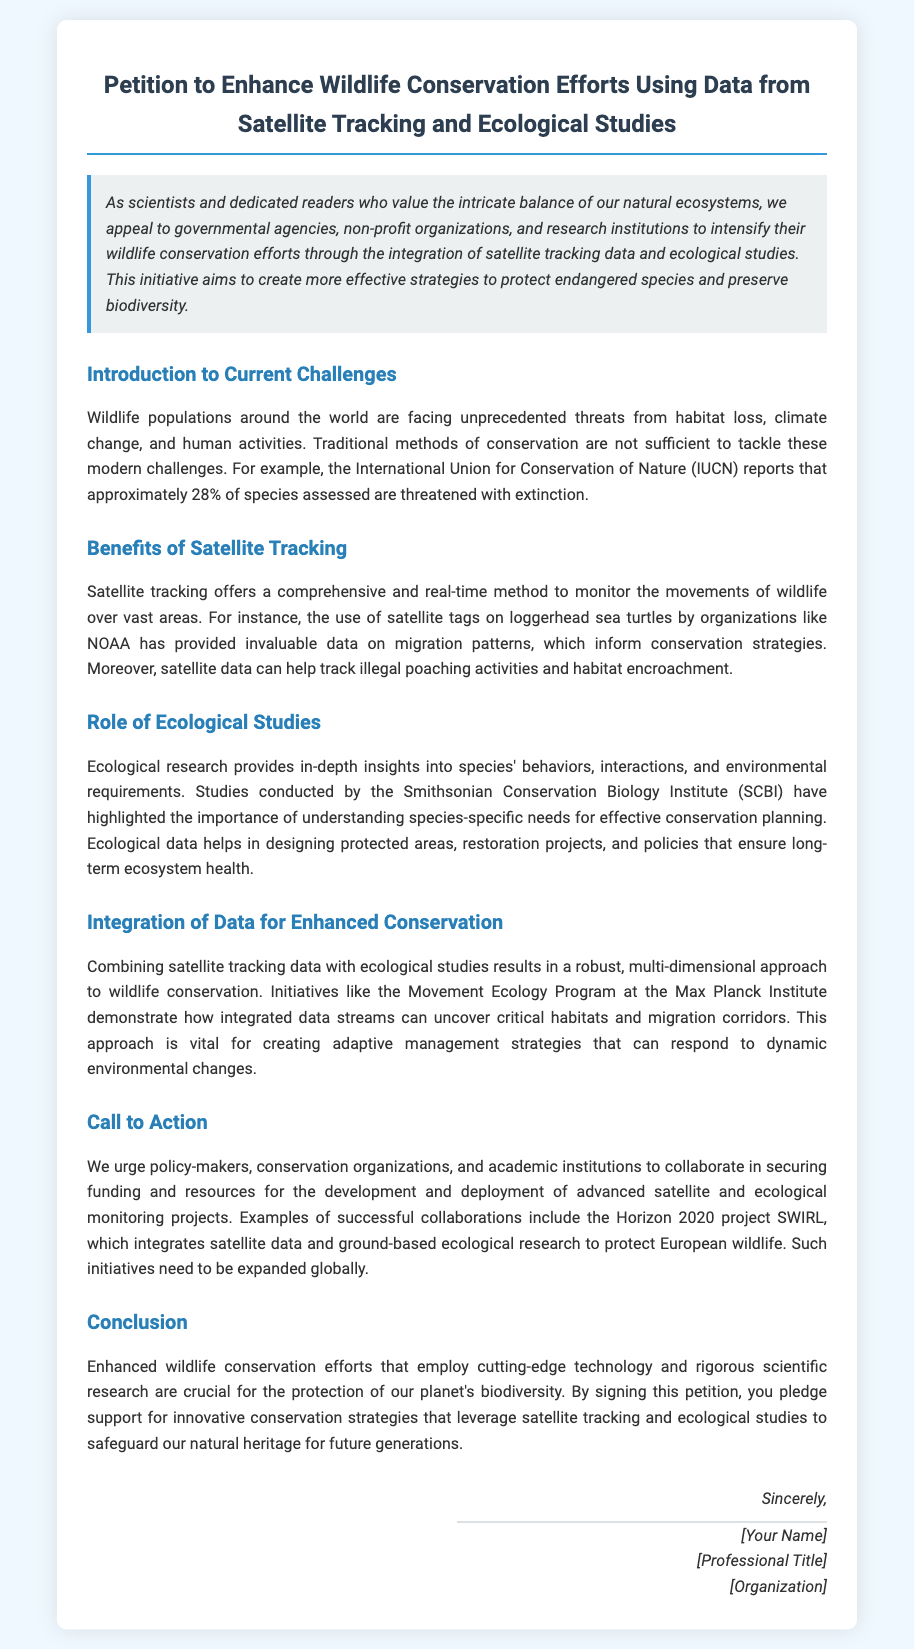What is the title of the petition? The title of the petition is clearly stated at the top of the document.
Answer: Petition to Enhance Wildlife Conservation Efforts Using Data from Satellite Tracking and Ecological Studies What organization reported that 28% of species are threatened with extinction? The document mentions the organization responsible for this statistic in the context of current challenges faced by wildlife populations.
Answer: International Union for Conservation of Nature (IUCN) Which animal was mentioned in relation to satellite tracking by NOAA? The petition provides a specific example of wildlife that benefits from satellite tracking in relation to conservation efforts.
Answer: Loggerhead sea turtles What program is mentioned as an example of integrated data for wildlife conservation? The document references a specific program that shows the effectiveness of combining different data streams for conservation efforts.
Answer: Movement Ecology Program at the Max Planck Institute What project is cited as a successful collaboration for the integration of monitoring projects? The petition lists an example of a project that successfully combines satellite data with ecological research.
Answer: Horizon 2020 project SWIRL What is the ultimate goal of signing this petition as stated in the conclusion? The conclusion highlights the main aim of the petition for those who support it.
Answer: Safeguard our natural heritage for future generations 